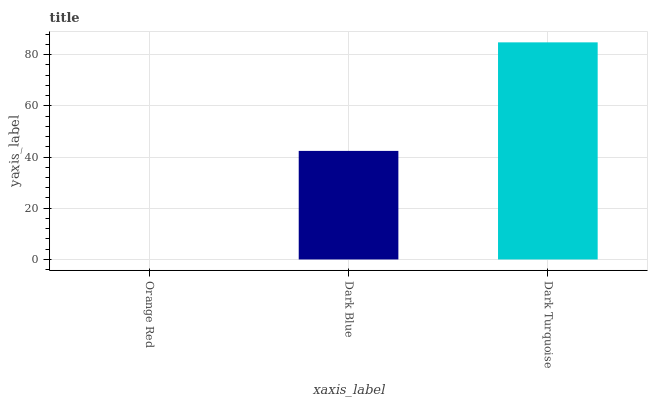Is Orange Red the minimum?
Answer yes or no. Yes. Is Dark Turquoise the maximum?
Answer yes or no. Yes. Is Dark Blue the minimum?
Answer yes or no. No. Is Dark Blue the maximum?
Answer yes or no. No. Is Dark Blue greater than Orange Red?
Answer yes or no. Yes. Is Orange Red less than Dark Blue?
Answer yes or no. Yes. Is Orange Red greater than Dark Blue?
Answer yes or no. No. Is Dark Blue less than Orange Red?
Answer yes or no. No. Is Dark Blue the high median?
Answer yes or no. Yes. Is Dark Blue the low median?
Answer yes or no. Yes. Is Dark Turquoise the high median?
Answer yes or no. No. Is Dark Turquoise the low median?
Answer yes or no. No. 